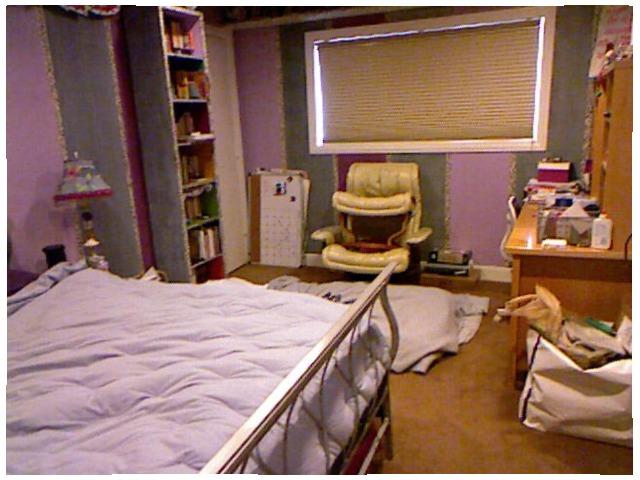<image>
Can you confirm if the bed is under the bed lamp? No. The bed is not positioned under the bed lamp. The vertical relationship between these objects is different. Is there a stool on the chair? Yes. Looking at the image, I can see the stool is positioned on top of the chair, with the chair providing support. Is the lamp to the left of the shelf? Yes. From this viewpoint, the lamp is positioned to the left side relative to the shelf. 